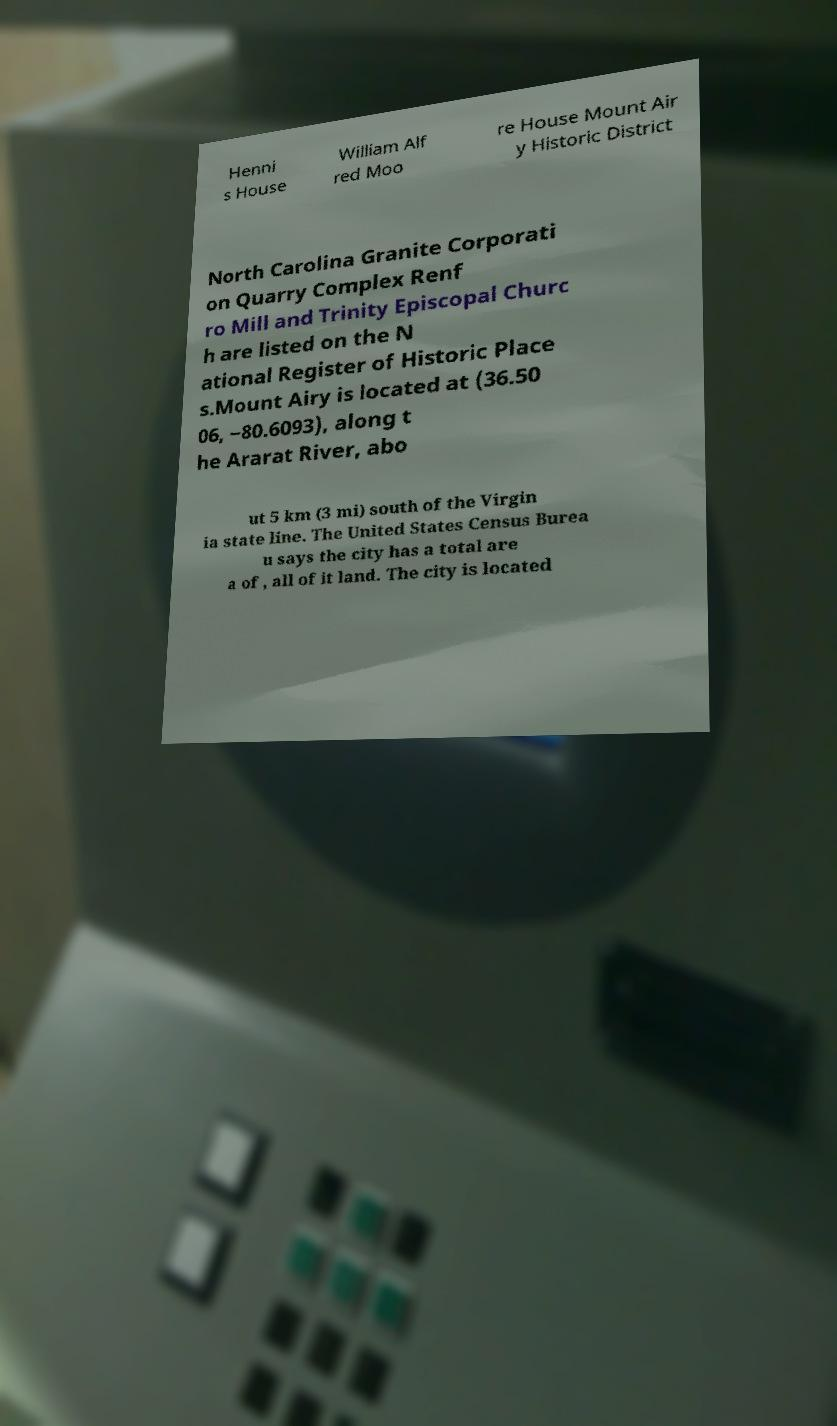What messages or text are displayed in this image? I need them in a readable, typed format. Henni s House William Alf red Moo re House Mount Air y Historic District North Carolina Granite Corporati on Quarry Complex Renf ro Mill and Trinity Episcopal Churc h are listed on the N ational Register of Historic Place s.Mount Airy is located at (36.50 06, −80.6093), along t he Ararat River, abo ut 5 km (3 mi) south of the Virgin ia state line. The United States Census Burea u says the city has a total are a of , all of it land. The city is located 